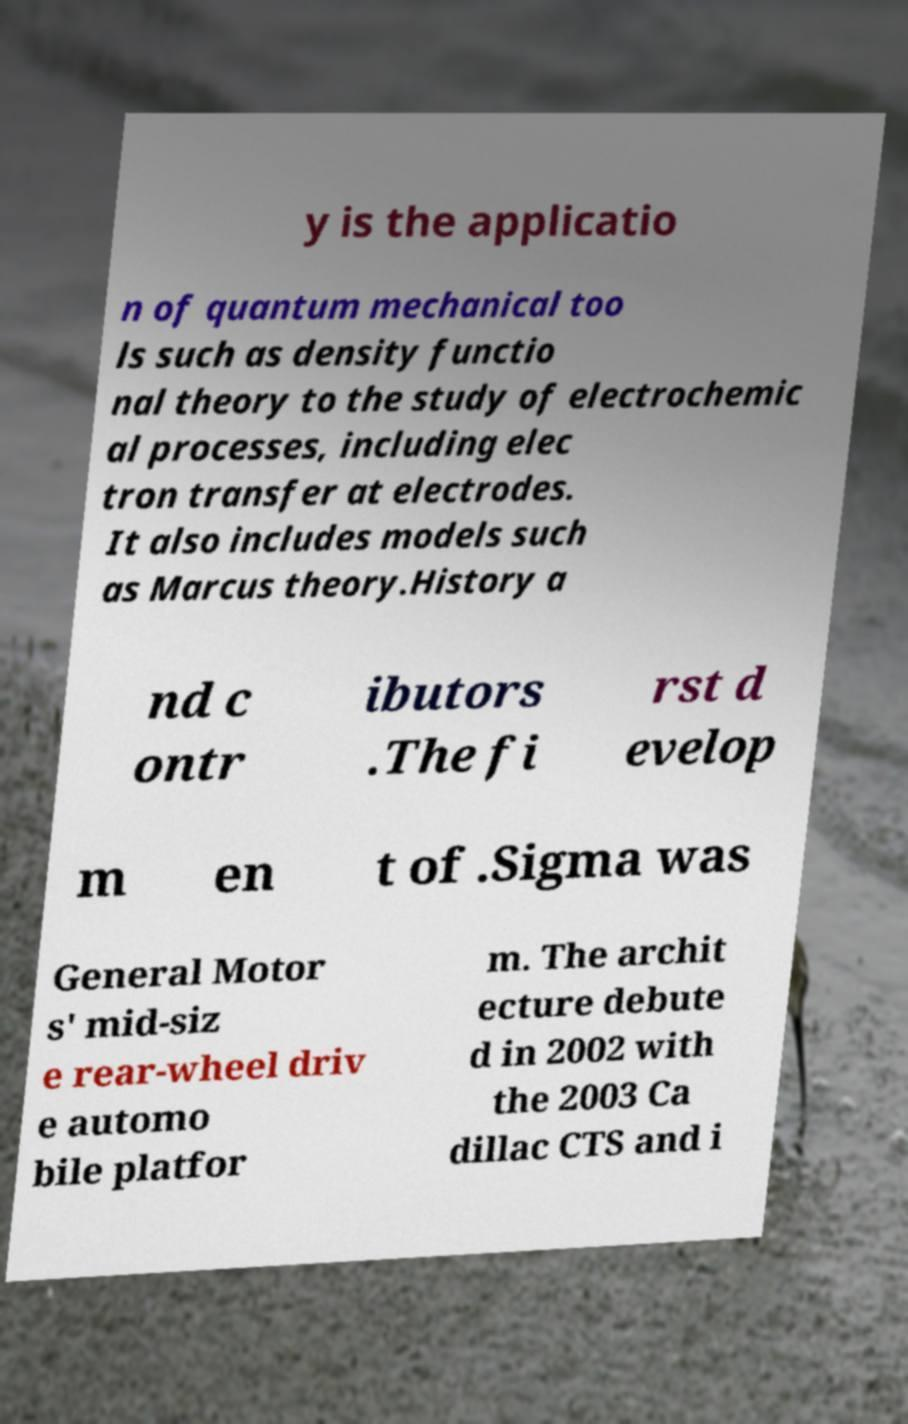Can you read and provide the text displayed in the image?This photo seems to have some interesting text. Can you extract and type it out for me? y is the applicatio n of quantum mechanical too ls such as density functio nal theory to the study of electrochemic al processes, including elec tron transfer at electrodes. It also includes models such as Marcus theory.History a nd c ontr ibutors .The fi rst d evelop m en t of .Sigma was General Motor s' mid-siz e rear-wheel driv e automo bile platfor m. The archit ecture debute d in 2002 with the 2003 Ca dillac CTS and i 